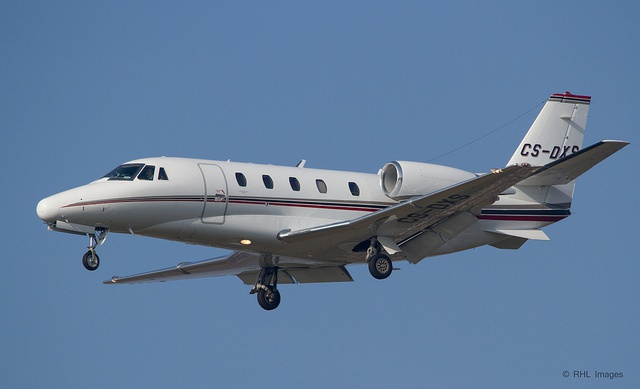Describe the objects in this image and their specific colors. I can see a airplane in gray, black, darkgray, and lightgray tones in this image. 